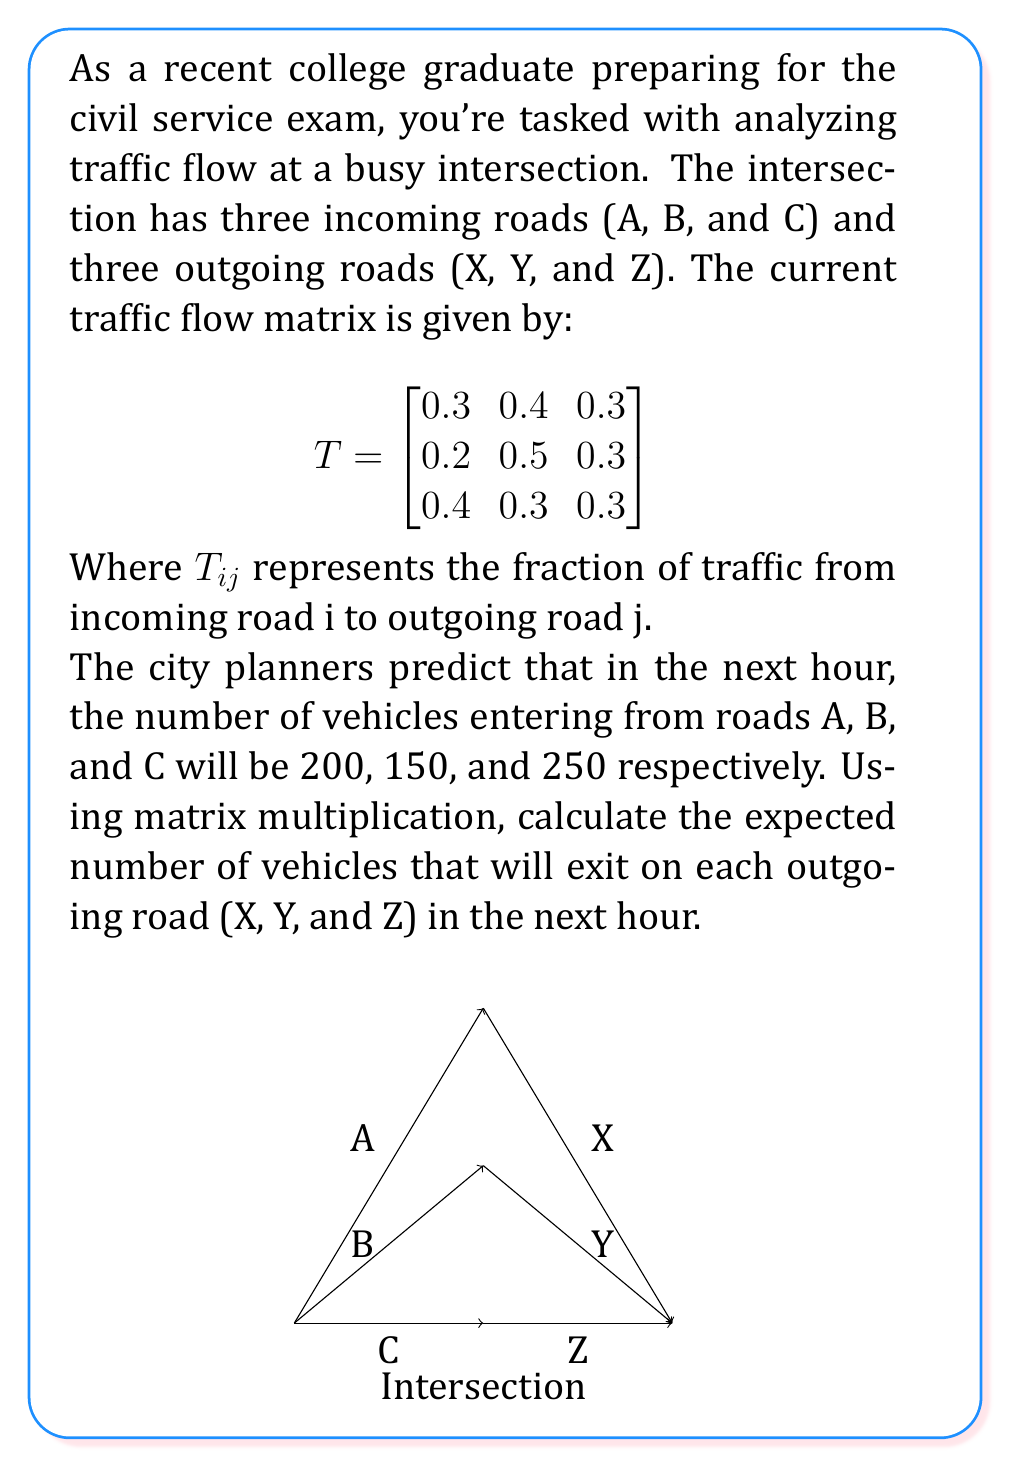Show me your answer to this math problem. Let's solve this problem step by step using matrix multiplication:

1) First, we need to set up our matrices. We have:

   Traffic flow matrix: 
   $$T = \begin{bmatrix}
   0.3 & 0.4 & 0.3 \\
   0.2 & 0.5 & 0.3 \\
   0.4 & 0.3 & 0.3
   \end{bmatrix}$$

   Incoming traffic vector:
   $$I = \begin{bmatrix}
   200 \\
   150 \\
   250
   \end{bmatrix}$$

2) To find the outgoing traffic, we need to multiply T by I:

   $$O = T \times I$$

3) Let's perform the matrix multiplication:

   $$\begin{bmatrix}
   0.3 & 0.4 & 0.3 \\
   0.2 & 0.5 & 0.3 \\
   0.4 & 0.3 & 0.3
   \end{bmatrix} \times 
   \begin{bmatrix}
   200 \\
   150 \\
   250
   \end{bmatrix}$$

4) Multiply each row of T by I:

   Row 1: $(0.3 \times 200) + (0.4 \times 150) + (0.3 \times 250) = 60 + 60 + 75 = 195$
   
   Row 2: $(0.2 \times 200) + (0.5 \times 150) + (0.3 \times 250) = 40 + 75 + 75 = 190$
   
   Row 3: $(0.4 \times 200) + (0.3 \times 150) + (0.3 \times 250) = 80 + 45 + 75 = 200$

5) Therefore, the outgoing traffic vector is:

   $$O = \begin{bmatrix}
   195 \\
   190 \\
   200
   \end{bmatrix}$$

This means that in the next hour, we expect 195 vehicles to exit on road X, 190 vehicles on road Y, and 200 vehicles on road Z.
Answer: X: 195, Y: 190, Z: 200 